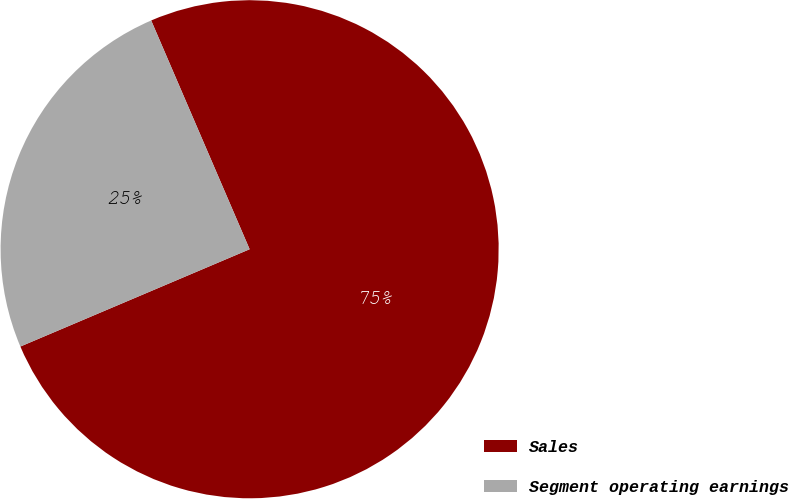Convert chart to OTSL. <chart><loc_0><loc_0><loc_500><loc_500><pie_chart><fcel>Sales<fcel>Segment operating earnings<nl><fcel>75.08%<fcel>24.92%<nl></chart> 